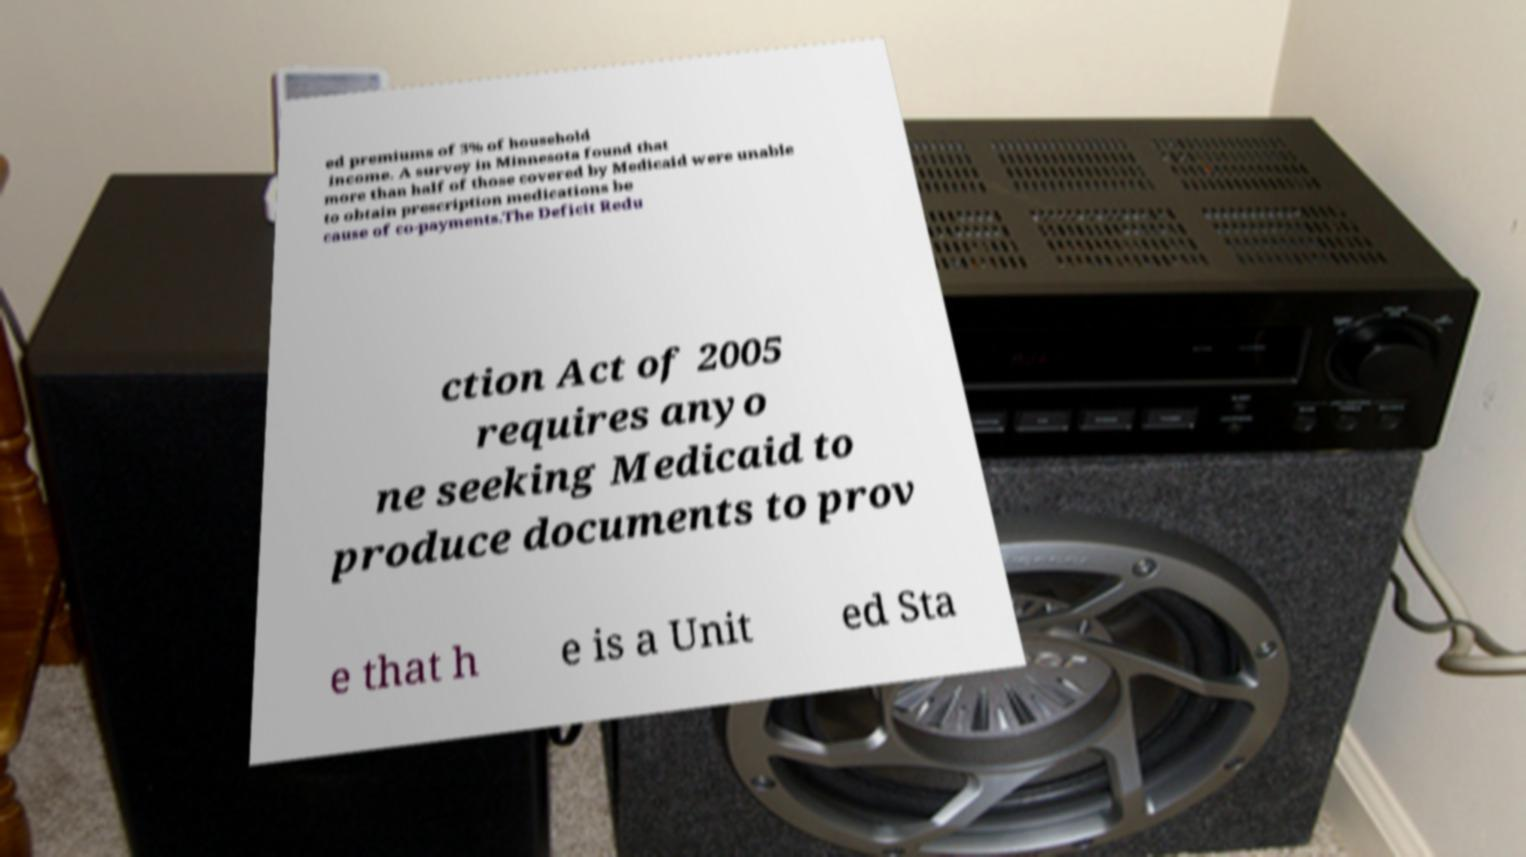I need the written content from this picture converted into text. Can you do that? ed premiums of 3% of household income. A survey in Minnesota found that more than half of those covered by Medicaid were unable to obtain prescription medications be cause of co-payments.The Deficit Redu ction Act of 2005 requires anyo ne seeking Medicaid to produce documents to prov e that h e is a Unit ed Sta 